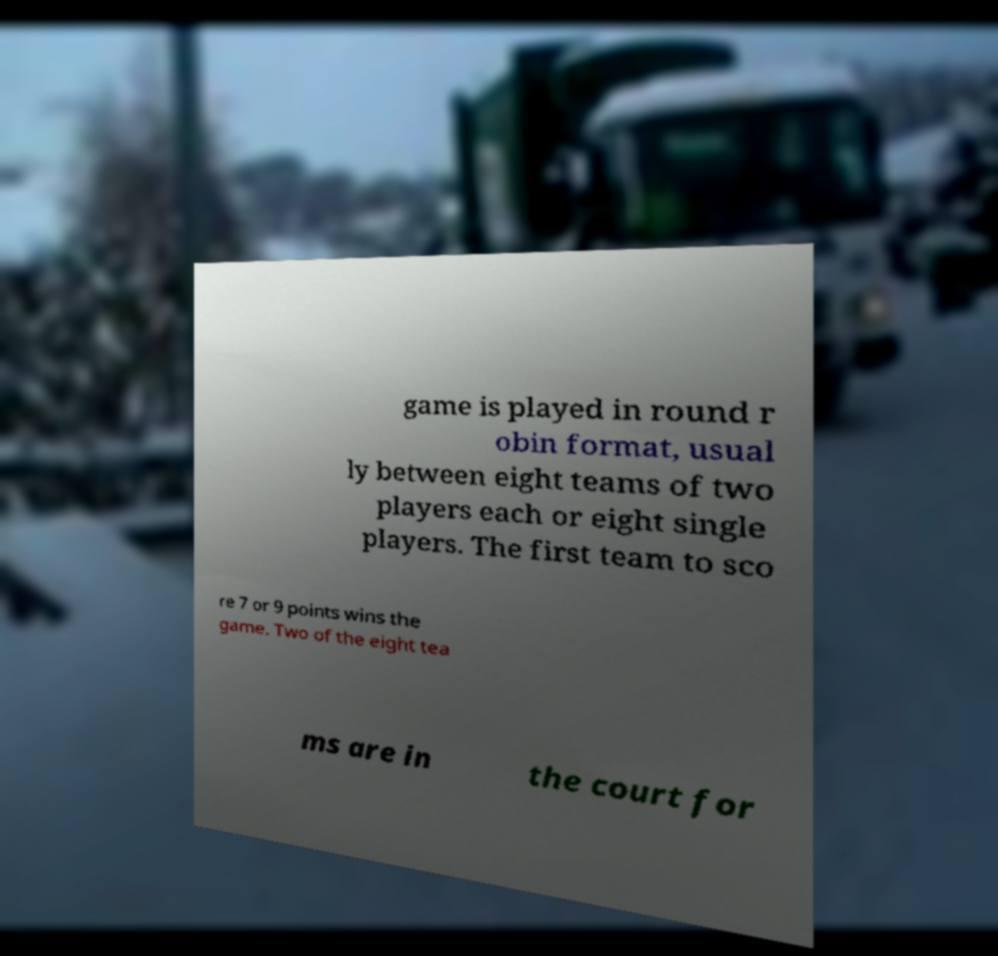Could you assist in decoding the text presented in this image and type it out clearly? game is played in round r obin format, usual ly between eight teams of two players each or eight single players. The first team to sco re 7 or 9 points wins the game. Two of the eight tea ms are in the court for 